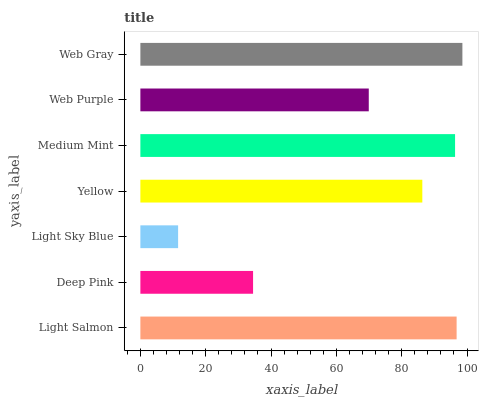Is Light Sky Blue the minimum?
Answer yes or no. Yes. Is Web Gray the maximum?
Answer yes or no. Yes. Is Deep Pink the minimum?
Answer yes or no. No. Is Deep Pink the maximum?
Answer yes or no. No. Is Light Salmon greater than Deep Pink?
Answer yes or no. Yes. Is Deep Pink less than Light Salmon?
Answer yes or no. Yes. Is Deep Pink greater than Light Salmon?
Answer yes or no. No. Is Light Salmon less than Deep Pink?
Answer yes or no. No. Is Yellow the high median?
Answer yes or no. Yes. Is Yellow the low median?
Answer yes or no. Yes. Is Deep Pink the high median?
Answer yes or no. No. Is Light Salmon the low median?
Answer yes or no. No. 